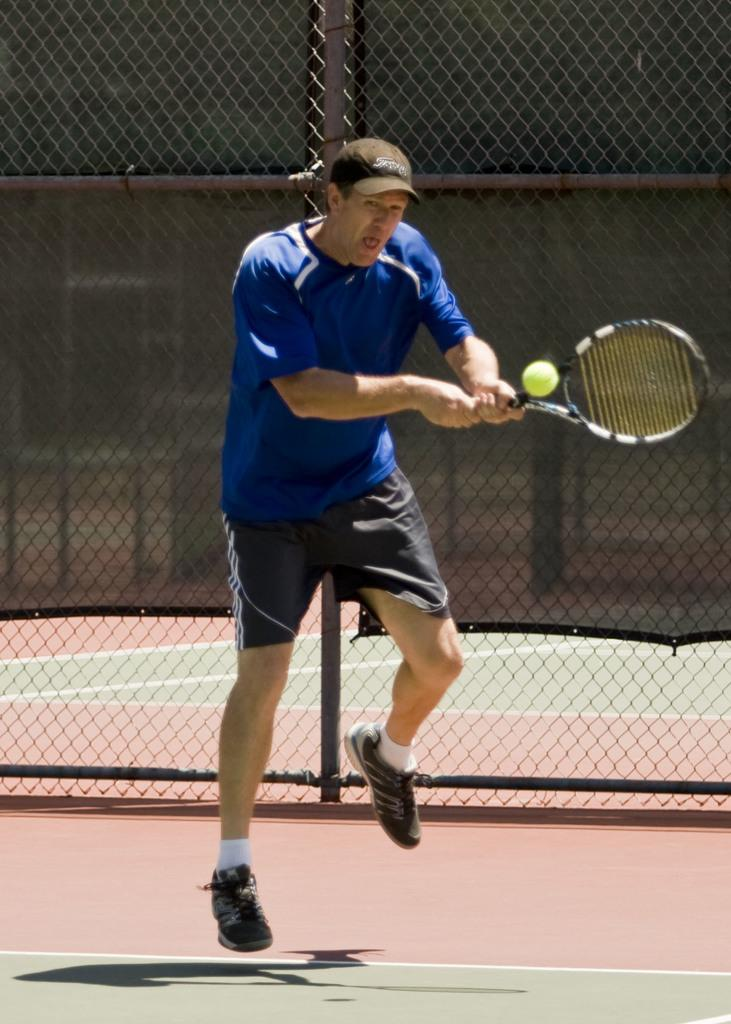Who is the main subject in the image? There is a man in the image. What is the man doing in the image? The man is jumping. What object is the man holding in the image? The man is holding a tennis racket. What action is the man performing with the tennis racket? The man is hitting a ball with the tennis racket. What type of pipe can be seen in the image? There is no pipe present in the image. How many eyes does the man have in the image? The image does not show the man's eyes, so it is impossible to determine the number of eyes. 